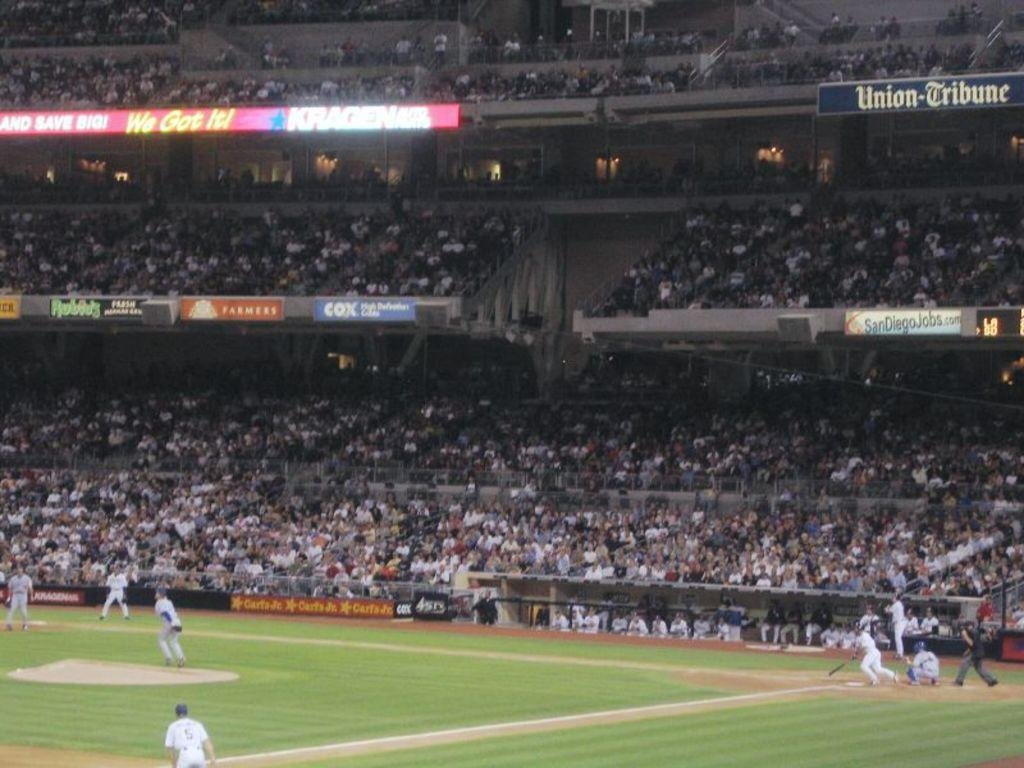<image>
Offer a succinct explanation of the picture presented. a baseball stadium filled with fans and sponsored by carls jr. 